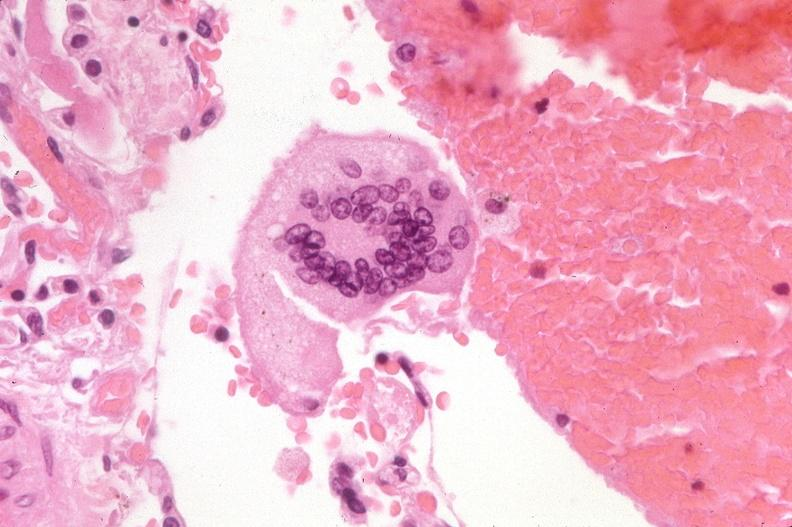where is this?
Answer the question using a single word or phrase. Lung 